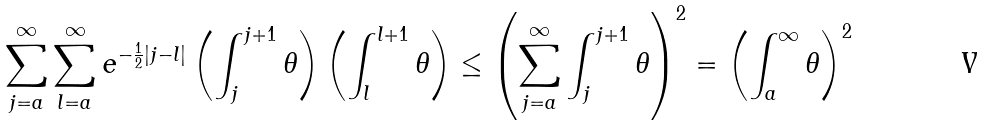<formula> <loc_0><loc_0><loc_500><loc_500>\sum _ { j = a } ^ { \infty } \sum _ { l = a } ^ { \infty } e ^ { - { \frac { 1 } { 2 } } | j - l | } \left ( \int _ { j } ^ { j + 1 } \theta \right ) \left ( \int _ { l } ^ { l + 1 } \theta \right ) \leq \left ( \sum _ { j = a } ^ { \infty } \int _ { j } ^ { j + 1 } \theta \right ) ^ { 2 } = \left ( \int _ { a } ^ { \infty } \theta \right ) ^ { 2 }</formula> 